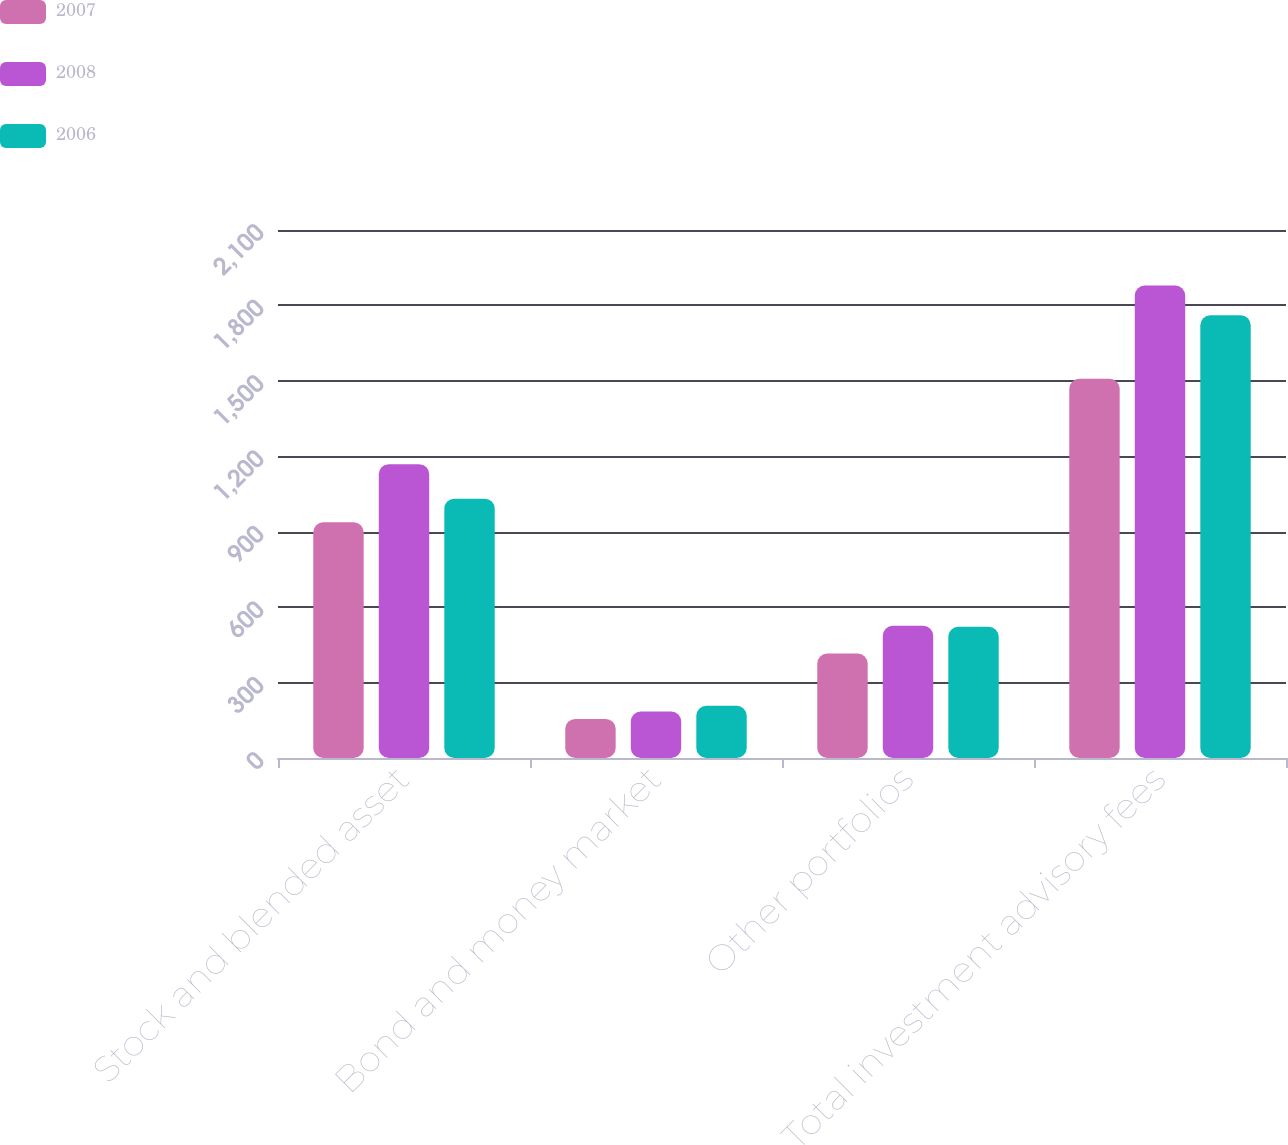Convert chart to OTSL. <chart><loc_0><loc_0><loc_500><loc_500><stacked_bar_chart><ecel><fcel>Stock and blended asset<fcel>Bond and money market<fcel>Other portfolios<fcel>Total investment advisory fees<nl><fcel>2007<fcel>937.5<fcel>155.6<fcel>415.4<fcel>1508.5<nl><fcel>2008<fcel>1168.7<fcel>184.6<fcel>525.8<fcel>1879.1<nl><fcel>2006<fcel>1031.4<fcel>207.4<fcel>522.2<fcel>1761<nl></chart> 